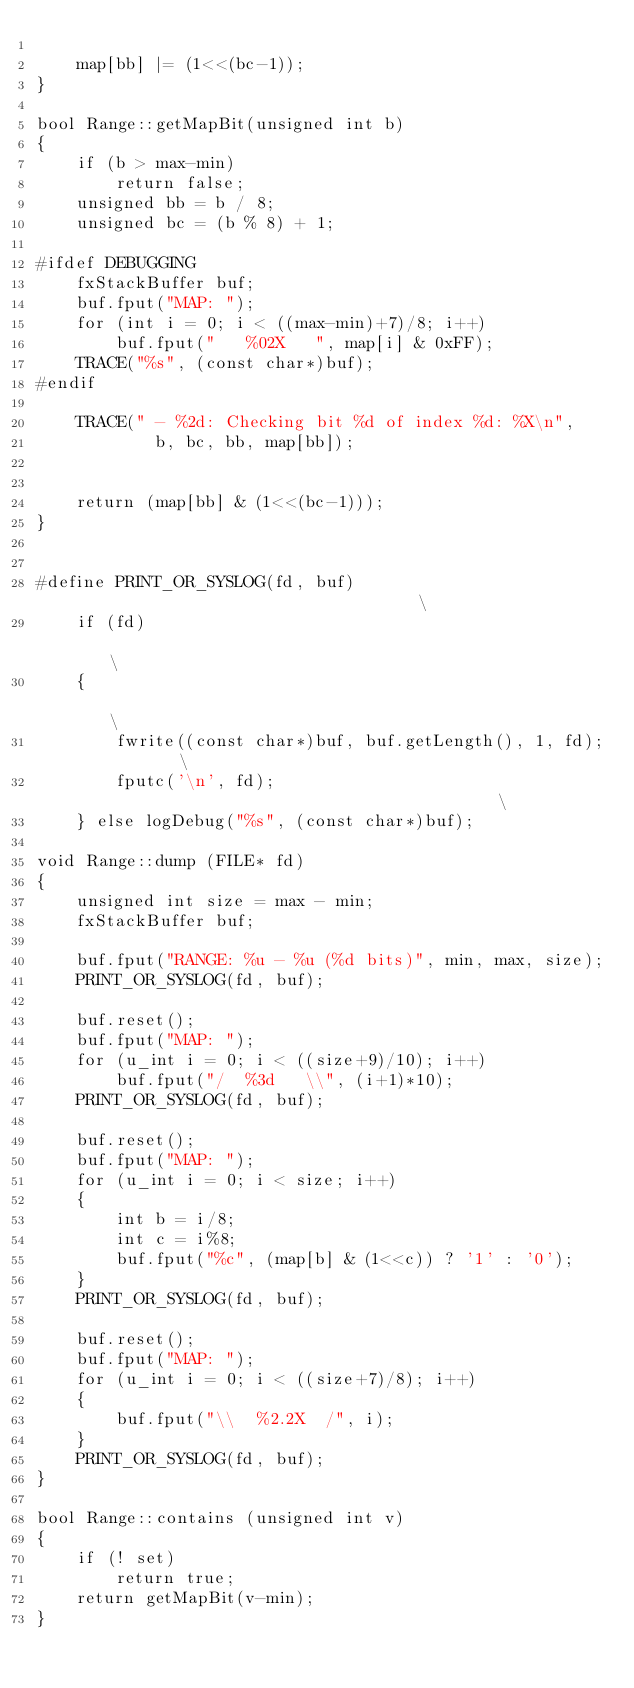<code> <loc_0><loc_0><loc_500><loc_500><_C++_>
	map[bb] |= (1<<(bc-1));
}

bool Range::getMapBit(unsigned int b)
{
	if (b > max-min)
	    return false;
	unsigned bb = b / 8;
	unsigned bc = (b % 8) + 1;

#ifdef DEBUGGING
	fxStackBuffer buf;
	buf.fput("MAP: ");
	for (int i = 0; i < ((max-min)+7)/8; i++)
		buf.fput("   %02X   ", map[i] & 0xFF);
	TRACE("%s", (const char*)buf);
#endif

	TRACE(" - %2d: Checking bit %d of index %d: %X\n",
			b, bc, bb, map[bb]);


	return (map[bb] & (1<<(bc-1)));
}


#define PRINT_OR_SYSLOG(fd, buf)                                    \
	if (fd)                                                     \
	{                                                           \
		fwrite((const char*)buf, buf.getLength(), 1, fd);   \
		fputc('\n', fd);                                    \
	} else logDebug("%s", (const char*)buf);

void Range::dump (FILE* fd)
{
	unsigned int size = max - min;
	fxStackBuffer buf;

	buf.fput("RANGE: %u - %u (%d bits)", min, max, size);
	PRINT_OR_SYSLOG(fd, buf);

	buf.reset();
	buf.fput("MAP: ");
	for (u_int i = 0; i < ((size+9)/10); i++)
		buf.fput("/  %3d   \\", (i+1)*10);
	PRINT_OR_SYSLOG(fd, buf);

	buf.reset();
	buf.fput("MAP: ");
	for (u_int i = 0; i < size; i++)
	{
		int b = i/8;
		int c = i%8;
		buf.fput("%c", (map[b] & (1<<c)) ? '1' : '0');
	}
	PRINT_OR_SYSLOG(fd, buf);

	buf.reset();
	buf.fput("MAP: ");
	for (u_int i = 0; i < ((size+7)/8); i++)
	{
		buf.fput("\\  %2.2X  /", i);
	}
	PRINT_OR_SYSLOG(fd, buf);
}

bool Range::contains (unsigned int v)
{
	if (! set)
		return true;
	return getMapBit(v-min);
}
</code> 